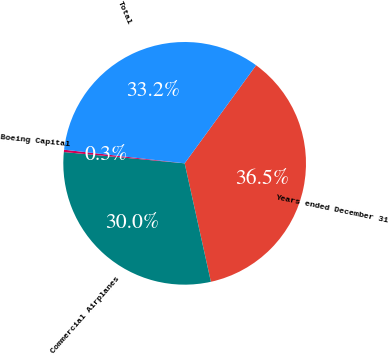Convert chart to OTSL. <chart><loc_0><loc_0><loc_500><loc_500><pie_chart><fcel>Years ended December 31<fcel>Commercial Airplanes<fcel>Boeing Capital<fcel>Total<nl><fcel>36.51%<fcel>29.95%<fcel>0.31%<fcel>33.23%<nl></chart> 